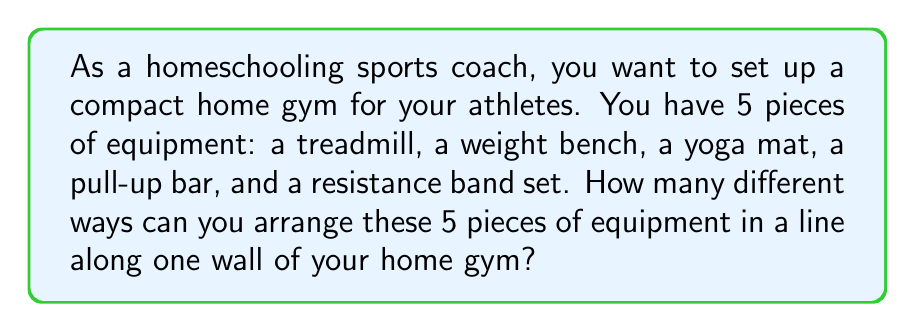Teach me how to tackle this problem. Let's approach this step-by-step:

1) This is a permutation problem. We need to arrange 5 distinct objects in a line.

2) For the first position, we have 5 choices of equipment.

3) For the second position, we have 4 remaining choices.

4) For the third position, we have 3 remaining choices.

5) For the fourth position, we have 2 remaining choices.

6) For the last position, we only have 1 choice left.

7) According to the multiplication principle, we multiply these numbers together:

   $$5 \times 4 \times 3 \times 2 \times 1 = 120$$

8) This is also known as 5 factorial, written as $5!$

Therefore, there are 120 different ways to arrange the 5 pieces of equipment along the wall.
Answer: $5! = 120$ ways 